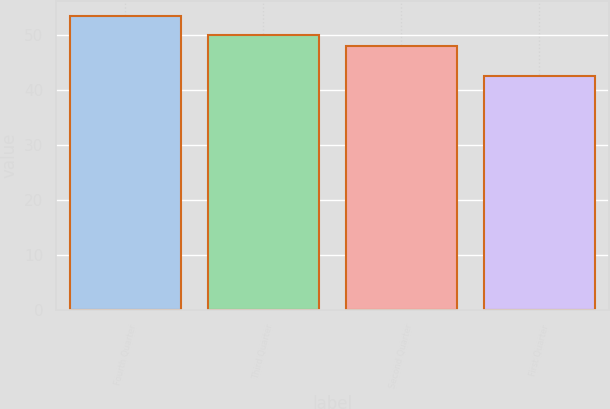Convert chart to OTSL. <chart><loc_0><loc_0><loc_500><loc_500><bar_chart><fcel>Fourth Quarter<fcel>Third Quarter<fcel>Second Quarter<fcel>First Quarter<nl><fcel>53.46<fcel>50<fcel>48.03<fcel>42.55<nl></chart> 